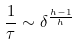<formula> <loc_0><loc_0><loc_500><loc_500>\frac { 1 } { \tau } \sim \delta ^ { \frac { h - 1 } { h } }</formula> 